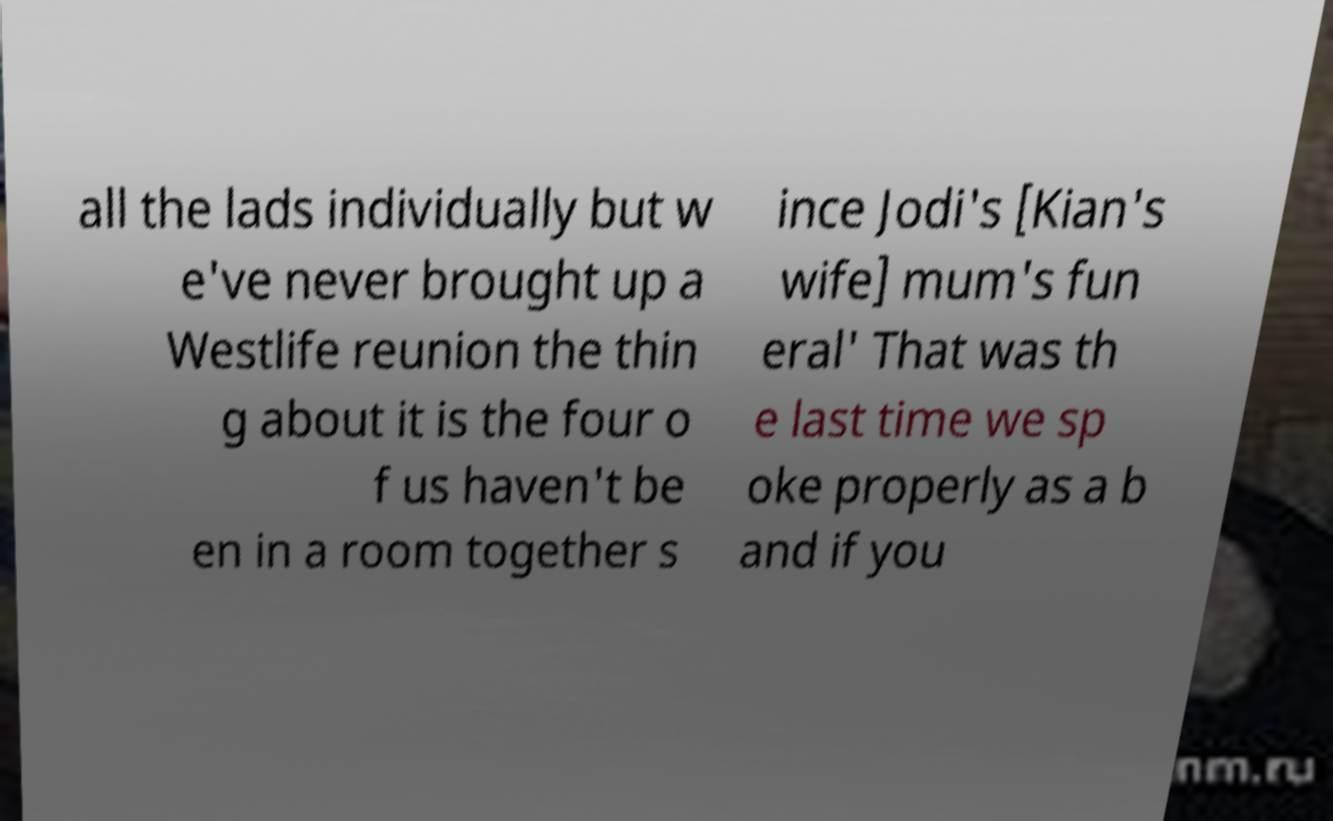Can you accurately transcribe the text from the provided image for me? all the lads individually but w e've never brought up a Westlife reunion the thin g about it is the four o f us haven't be en in a room together s ince Jodi's [Kian's wife] mum's fun eral' That was th e last time we sp oke properly as a b and if you 